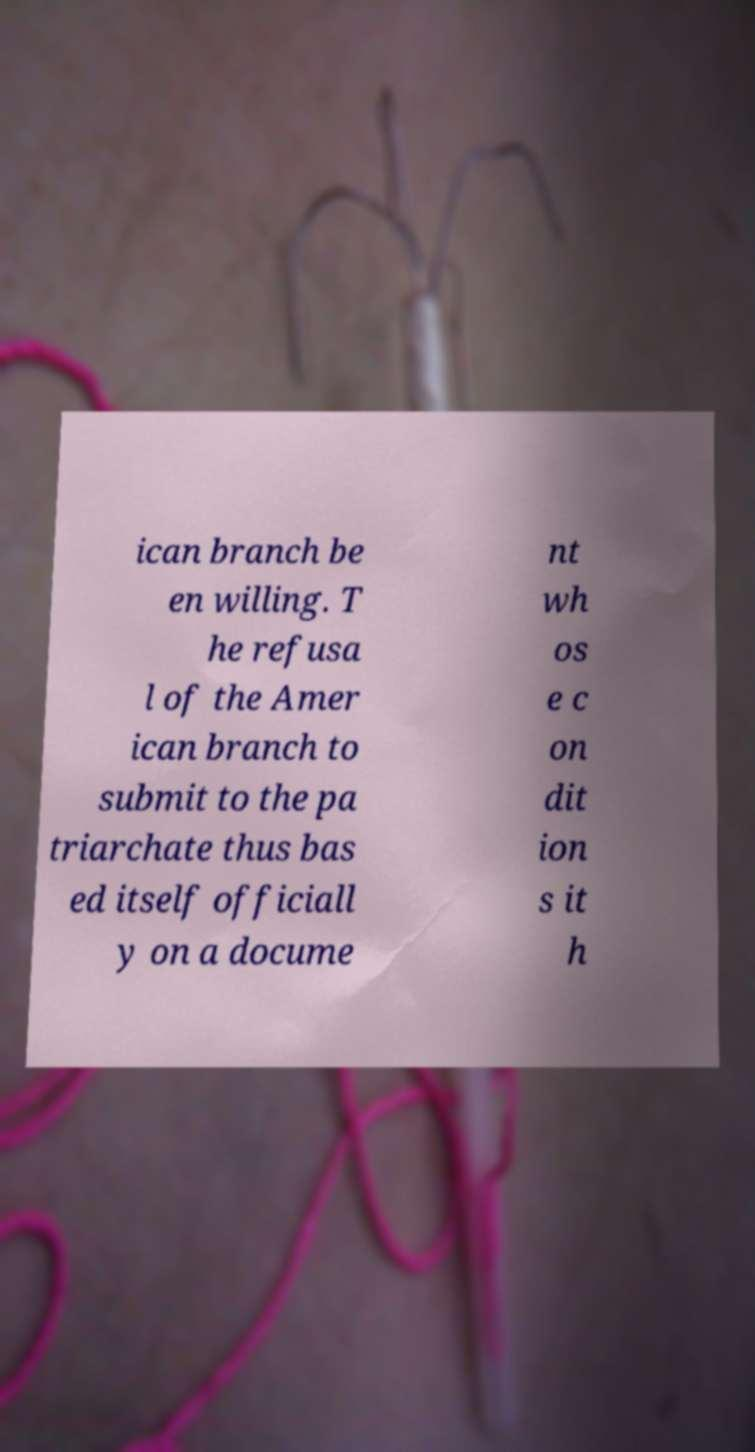For documentation purposes, I need the text within this image transcribed. Could you provide that? ican branch be en willing. T he refusa l of the Amer ican branch to submit to the pa triarchate thus bas ed itself officiall y on a docume nt wh os e c on dit ion s it h 